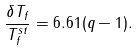Convert formula to latex. <formula><loc_0><loc_0><loc_500><loc_500>\frac { \delta T _ { f } } { T _ { f } ^ { s t } } = 6 . 6 1 ( q - 1 ) .</formula> 